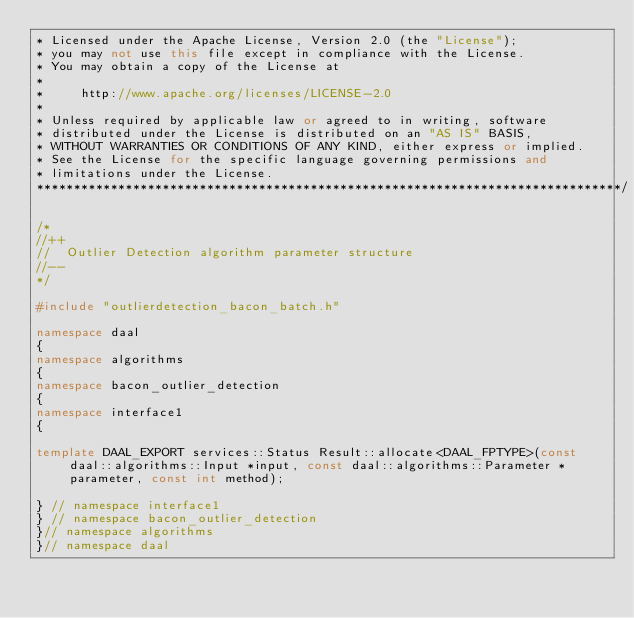Convert code to text. <code><loc_0><loc_0><loc_500><loc_500><_C++_>* Licensed under the Apache License, Version 2.0 (the "License");
* you may not use this file except in compliance with the License.
* You may obtain a copy of the License at
*
*     http://www.apache.org/licenses/LICENSE-2.0
*
* Unless required by applicable law or agreed to in writing, software
* distributed under the License is distributed on an "AS IS" BASIS,
* WITHOUT WARRANTIES OR CONDITIONS OF ANY KIND, either express or implied.
* See the License for the specific language governing permissions and
* limitations under the License.
*******************************************************************************/

/*
//++
//  Outlier Detection algorithm parameter structure
//--
*/

#include "outlierdetection_bacon_batch.h"

namespace daal
{
namespace algorithms
{
namespace bacon_outlier_detection
{
namespace interface1
{

template DAAL_EXPORT services::Status Result::allocate<DAAL_FPTYPE>(const daal::algorithms::Input *input, const daal::algorithms::Parameter *parameter, const int method);

} // namespace interface1
} // namespace bacon_outlier_detection
}// namespace algorithms
}// namespace daal
</code> 